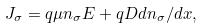Convert formula to latex. <formula><loc_0><loc_0><loc_500><loc_500>J _ { \sigma } = q \mu n _ { \sigma } E + q D d n _ { \sigma } / d x ,</formula> 